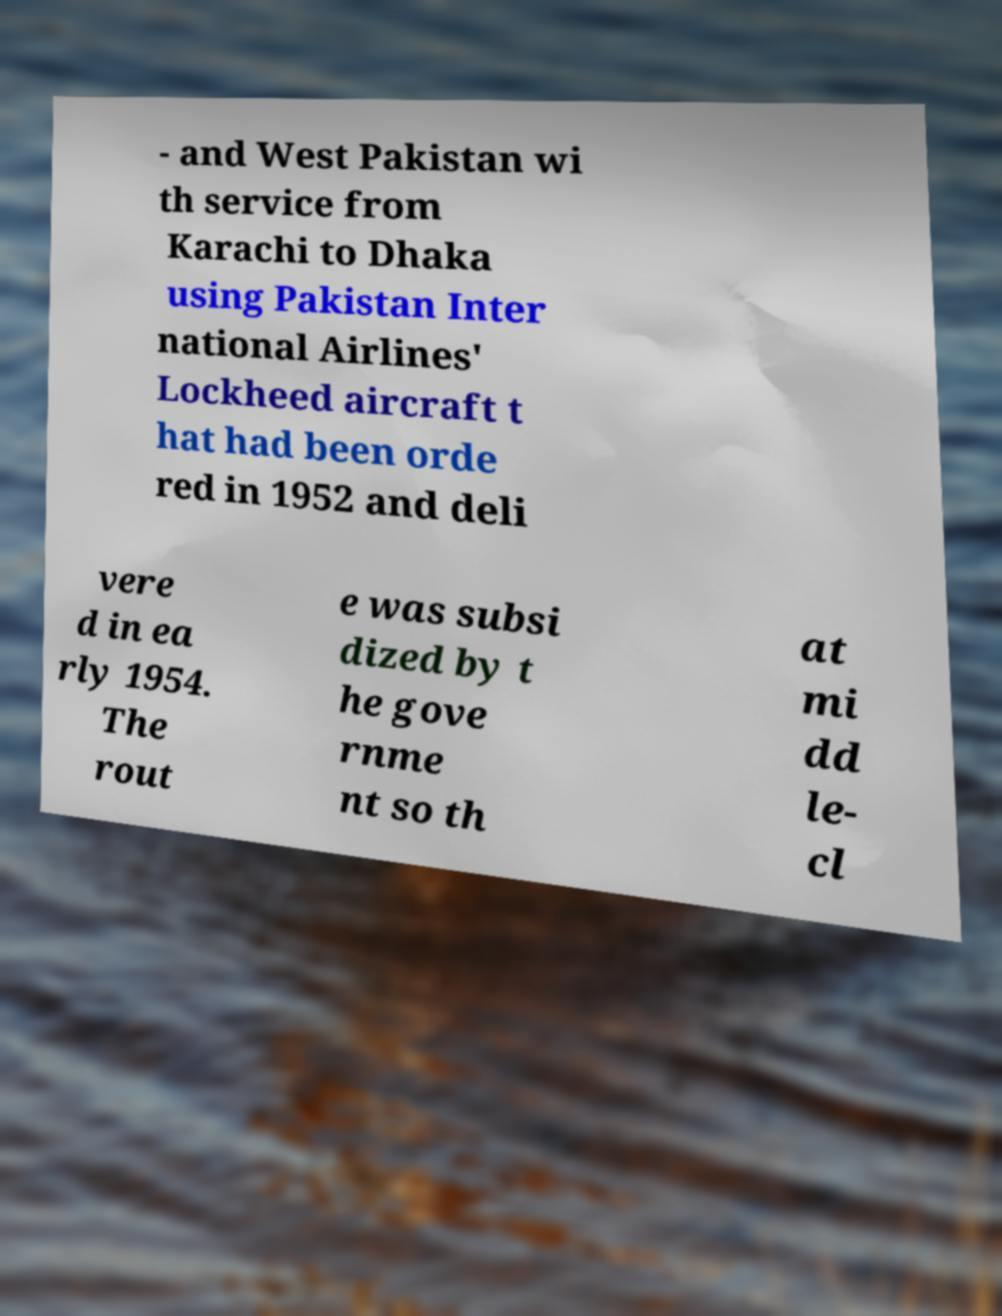Can you read and provide the text displayed in the image?This photo seems to have some interesting text. Can you extract and type it out for me? - and West Pakistan wi th service from Karachi to Dhaka using Pakistan Inter national Airlines' Lockheed aircraft t hat had been orde red in 1952 and deli vere d in ea rly 1954. The rout e was subsi dized by t he gove rnme nt so th at mi dd le- cl 